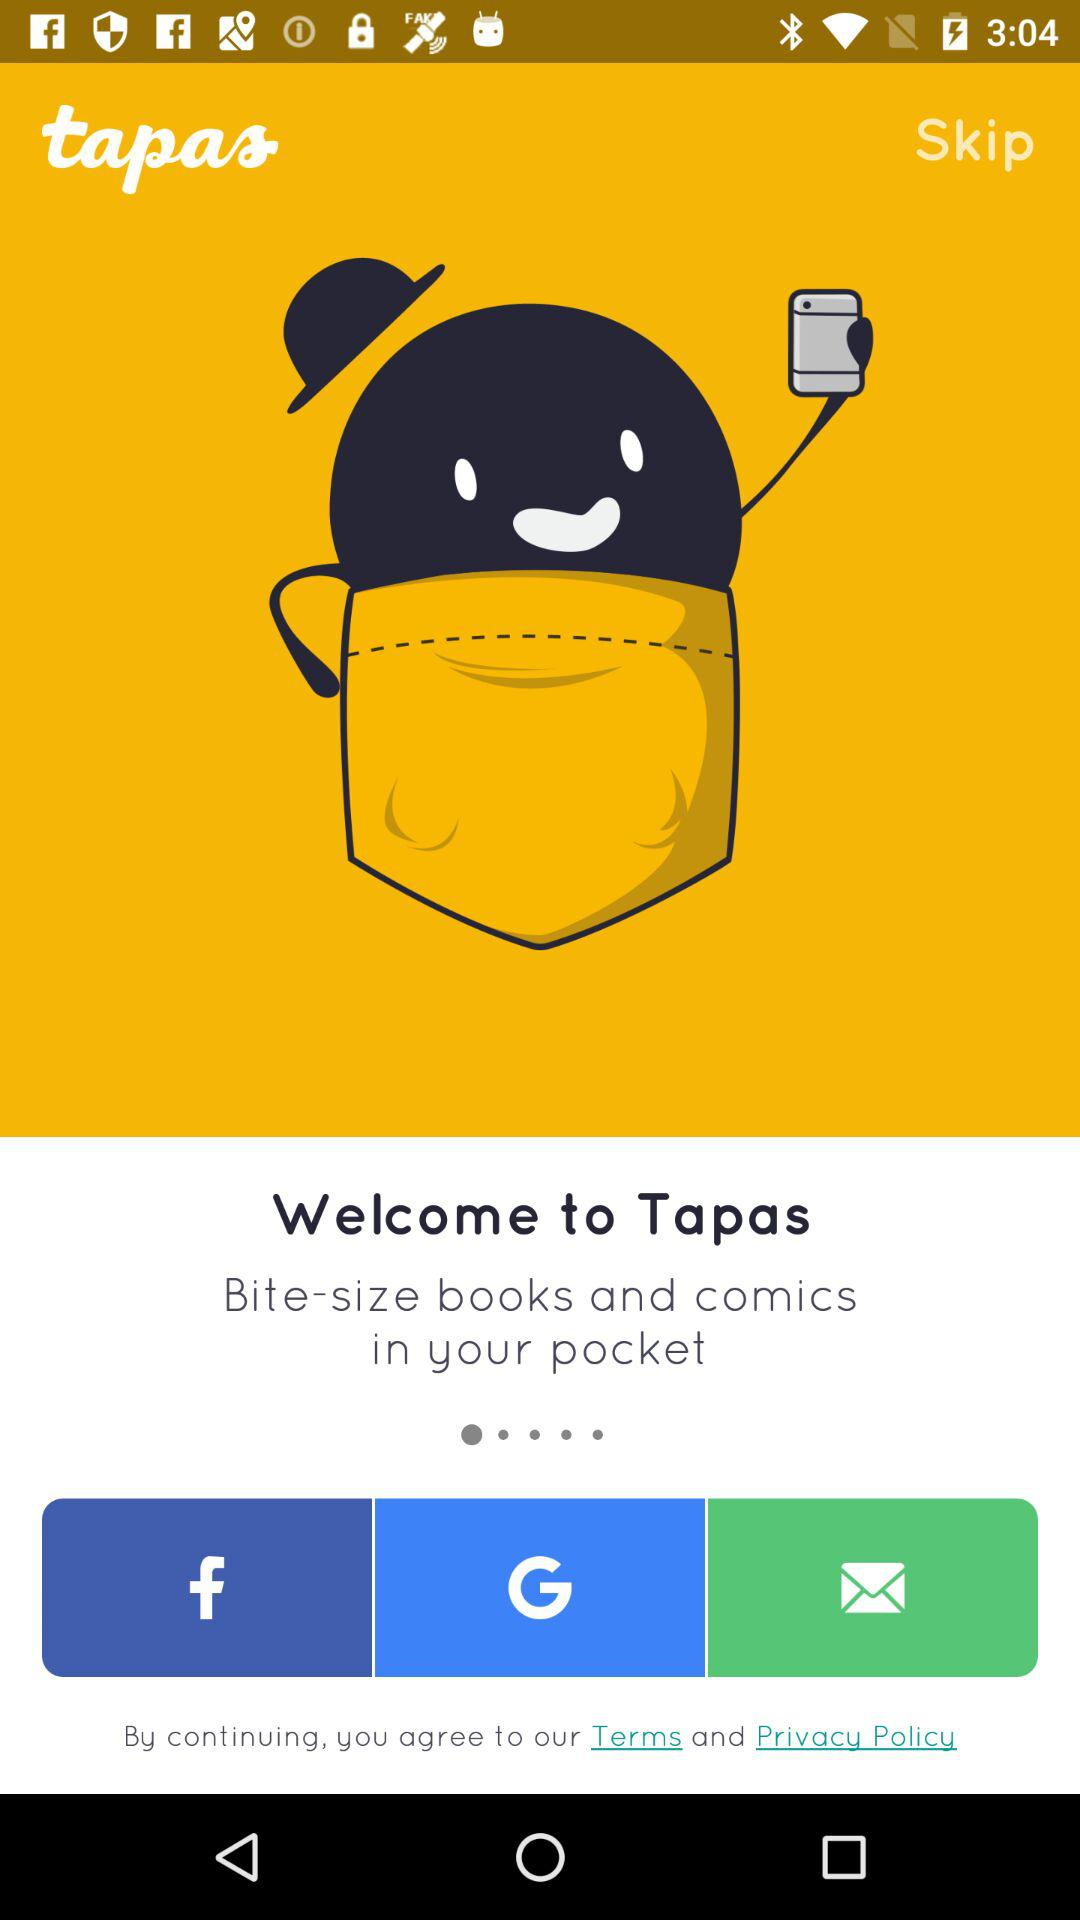What are the different options available for logging in? The different options available for logging in are "Facebook", "Google" and "Email". 